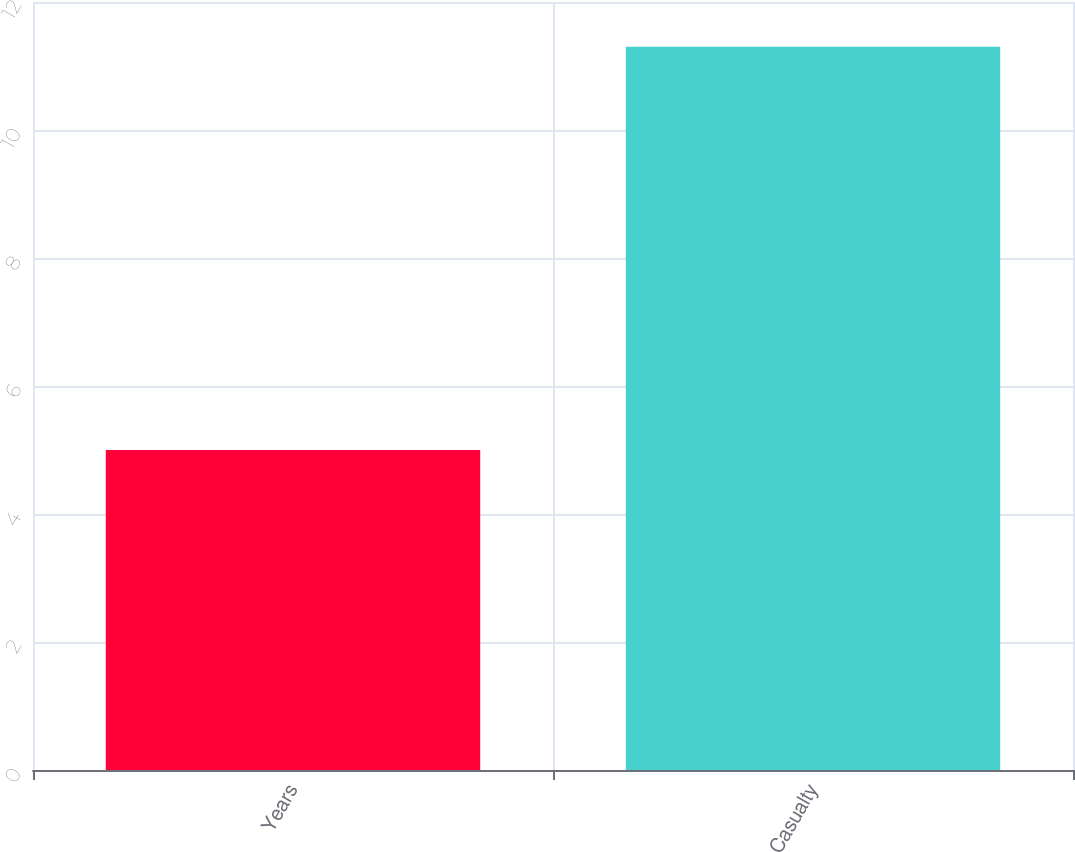<chart> <loc_0><loc_0><loc_500><loc_500><bar_chart><fcel>Years<fcel>Casualty<nl><fcel>5<fcel>11.3<nl></chart> 